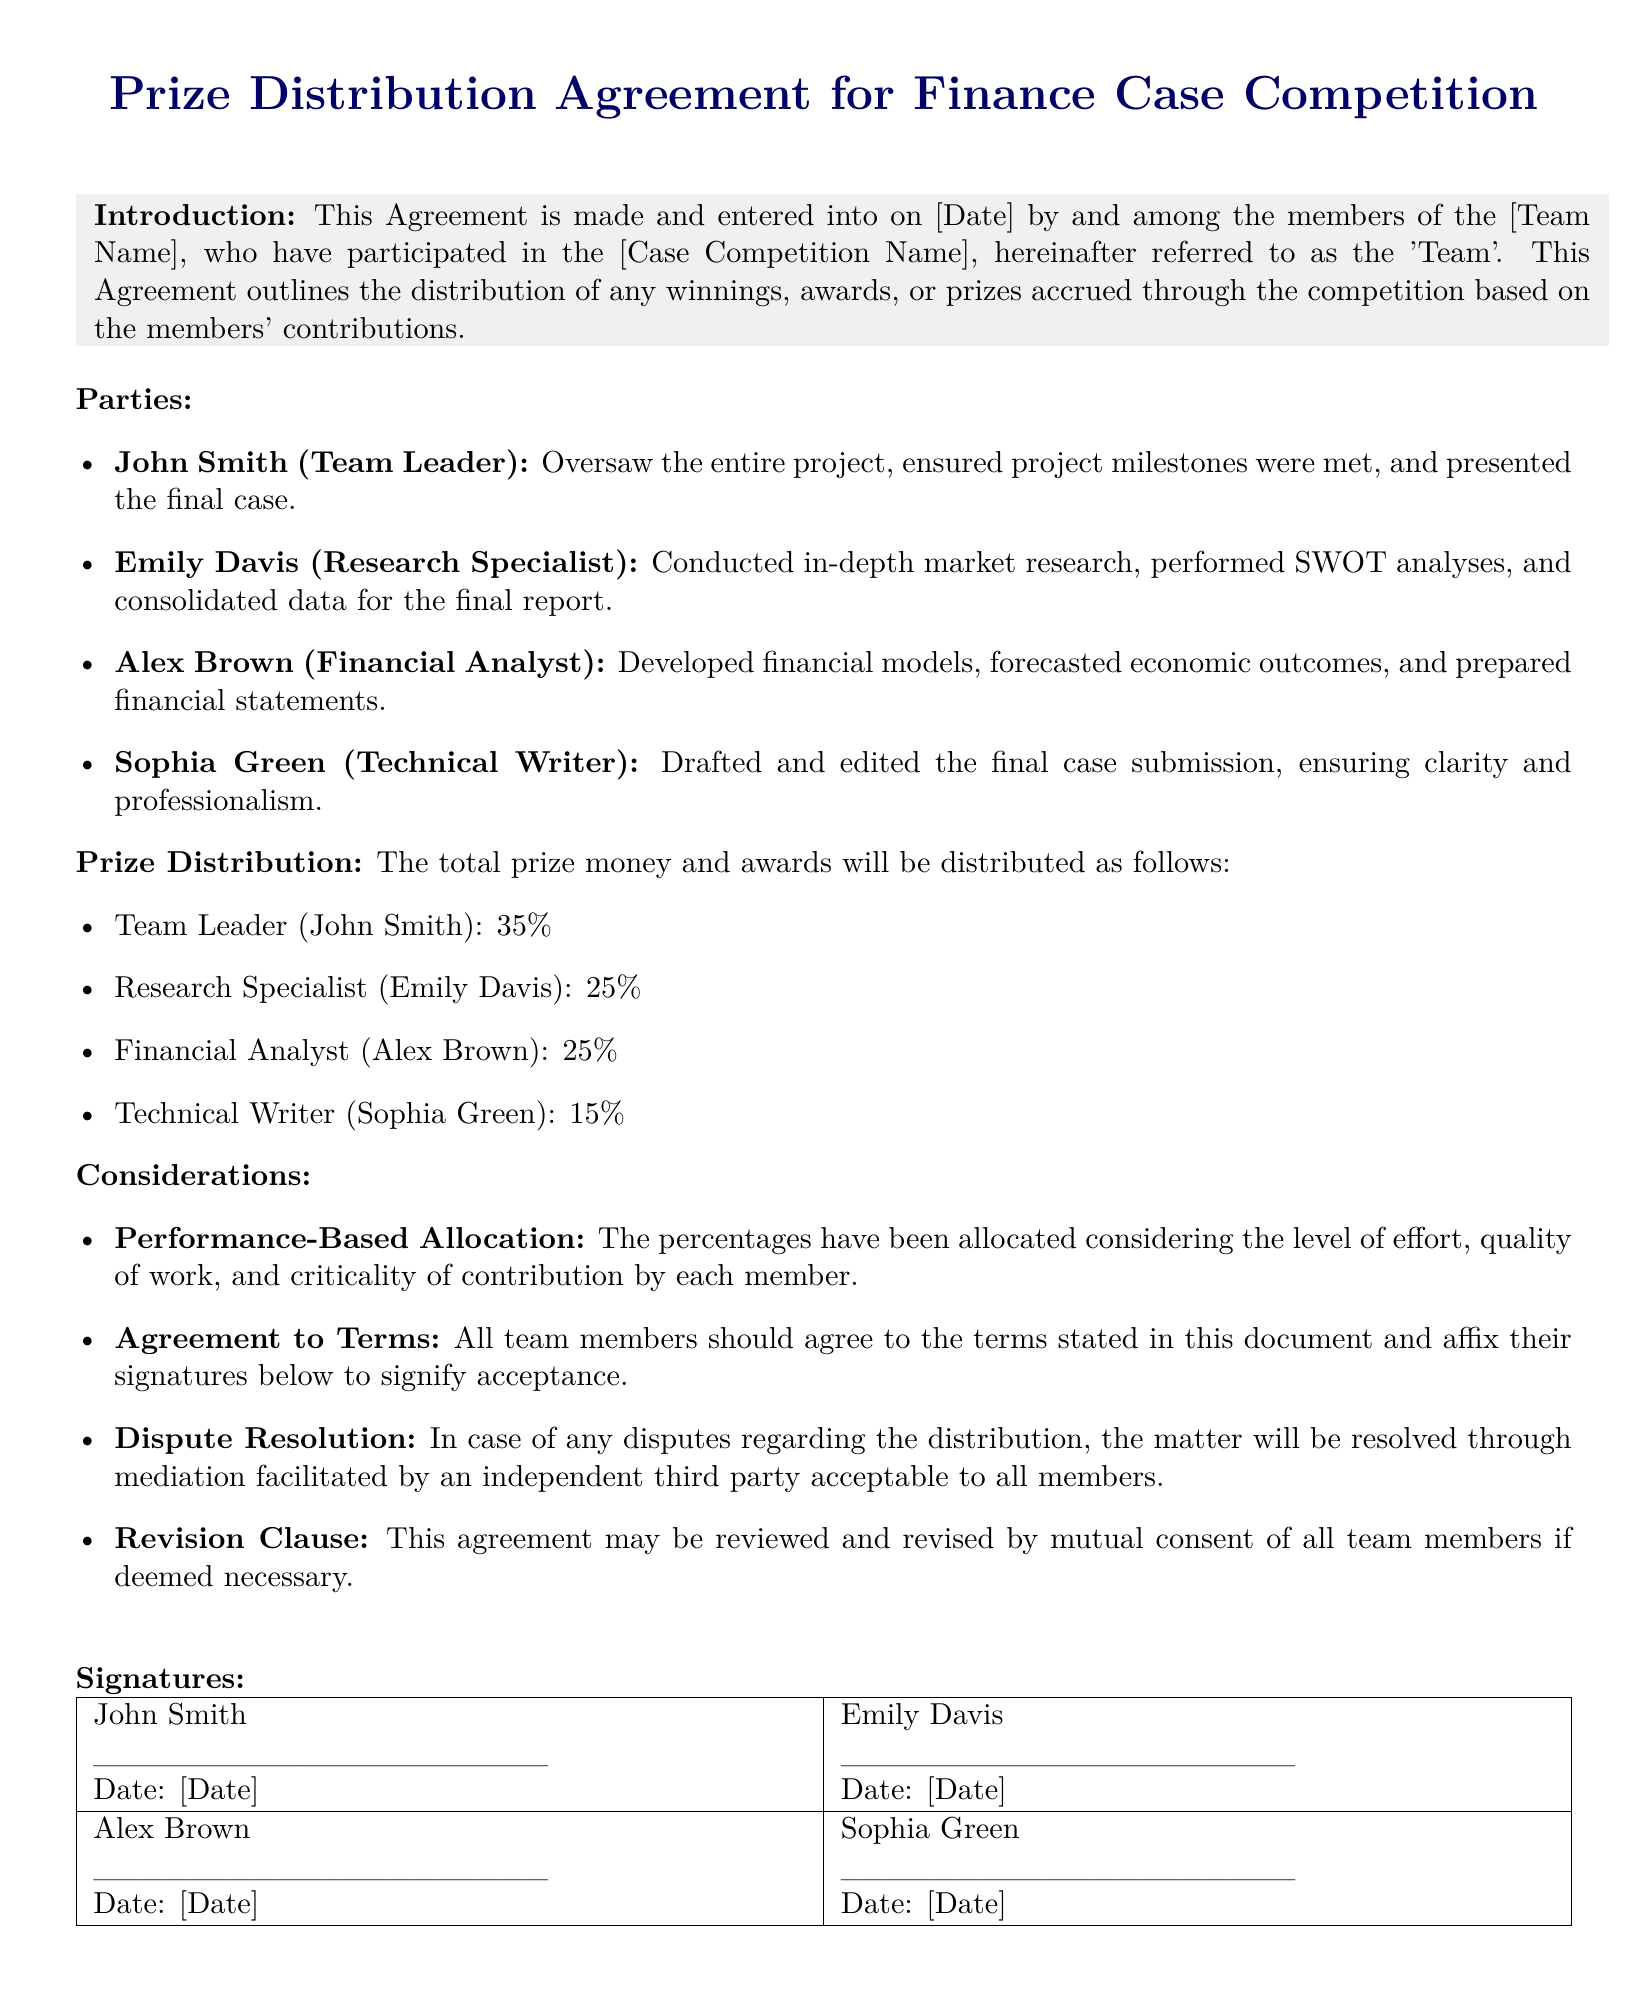What is the date of the agreement? The date of the agreement is mentioned as [Date] in the introduction.
Answer: [Date] Who is the team leader? The team leader's name is specifically listed in the parties section of the document.
Answer: John Smith What percentage does Emily Davis receive? The prize distribution section states the allocated percentage to Emily Davis.
Answer: 25% What is the main method of dispute resolution? The considerations section describes how disputes will be resolved, indicating the process.
Answer: Mediation How many members are in the team? The parties section lists the individuals involved in the agreement, allowing us to count them.
Answer: Four What role did Sophia Green play in the team? The parties section clearly defines the roles of each team member, indicating Sophia's contribution.
Answer: Technical Writer What is the revision clause about? The considerations section mentions a specific point regarding mutual consent for revising the agreement.
Answer: Review and revise by mutual consent What is the distribution percentage for the Financial Analyst? In the prize distribution section, the allocation for the Financial Analyst is stated clearly.
Answer: 25% Who conducted market research? The specific contributions of each member are detailed in the parties section, identifying the responsible person for research.
Answer: Emily Davis 